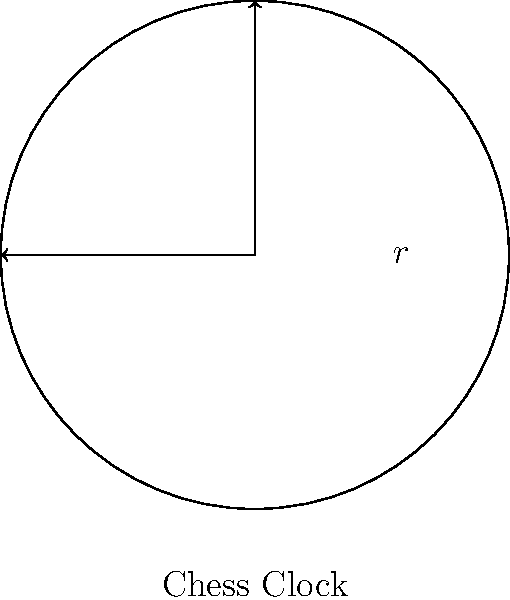A circular chess clock face has a radius of 5 cm. What is the area of the clock face in square centimeters? Round your answer to two decimal places. To find the area of a circular chess clock face, we need to use the formula for the area of a circle:

$$A = \pi r^2$$

Where:
$A$ = area of the circle
$\pi$ = pi (approximately 3.14159)
$r$ = radius of the circle

Given:
$r = 5$ cm

Let's substitute the values into the formula:

$$A = \pi (5)^2$$
$$A = \pi (25)$$
$$A = 25\pi$$

Now, let's calculate this value:
$$A = 25 \times 3.14159$$
$$A = 78.53975$$

Rounding to two decimal places:
$$A \approx 78.54 \text{ cm}^2$$
Answer: $78.54 \text{ cm}^2$ 